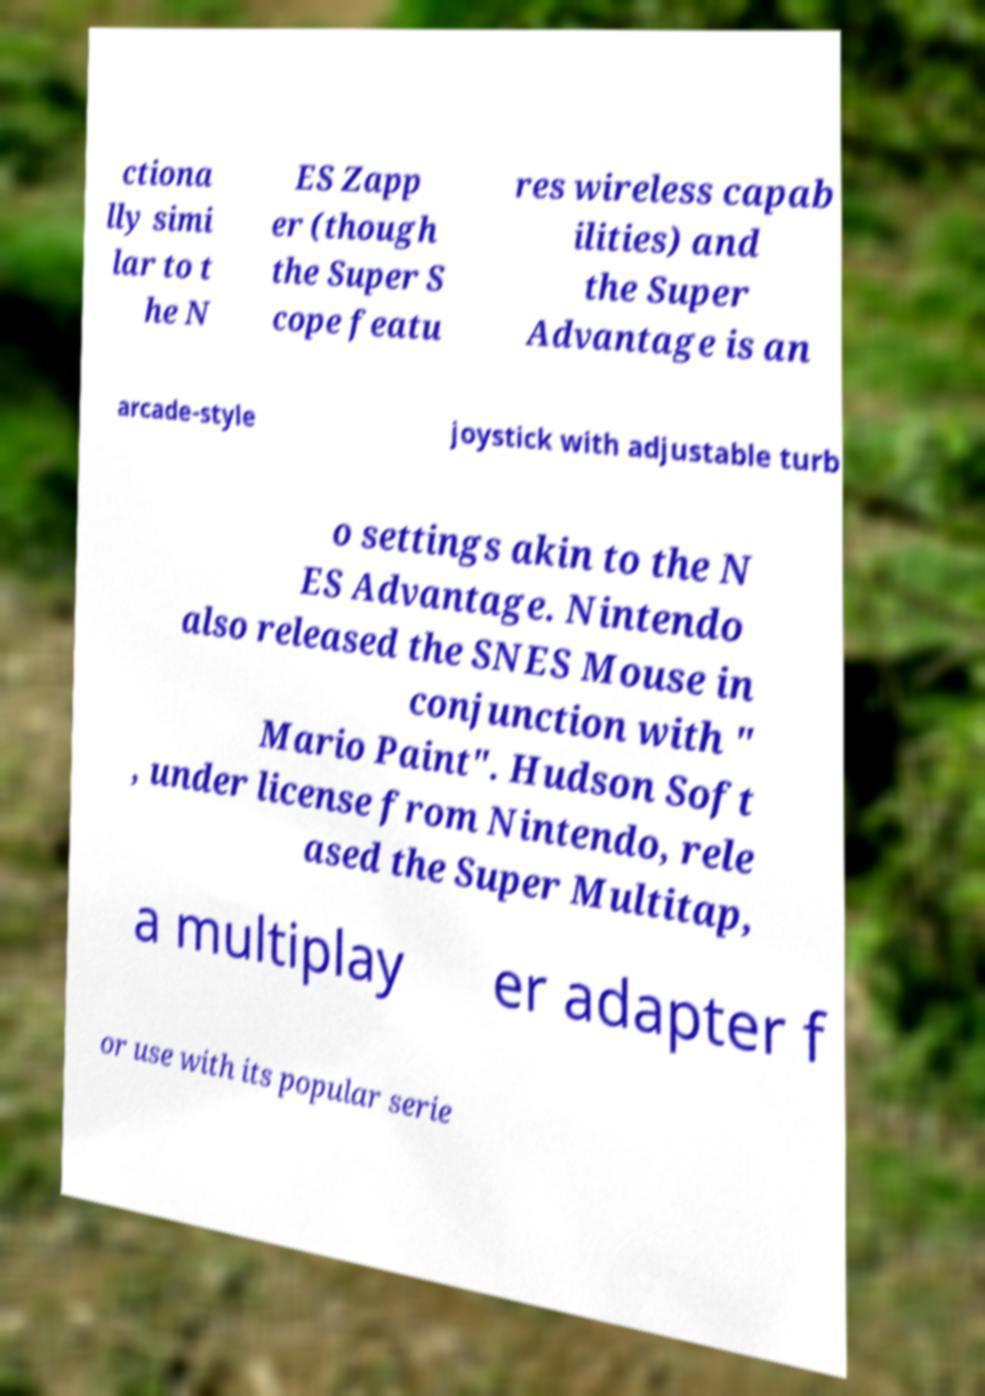For documentation purposes, I need the text within this image transcribed. Could you provide that? ctiona lly simi lar to t he N ES Zapp er (though the Super S cope featu res wireless capab ilities) and the Super Advantage is an arcade-style joystick with adjustable turb o settings akin to the N ES Advantage. Nintendo also released the SNES Mouse in conjunction with " Mario Paint". Hudson Soft , under license from Nintendo, rele ased the Super Multitap, a multiplay er adapter f or use with its popular serie 